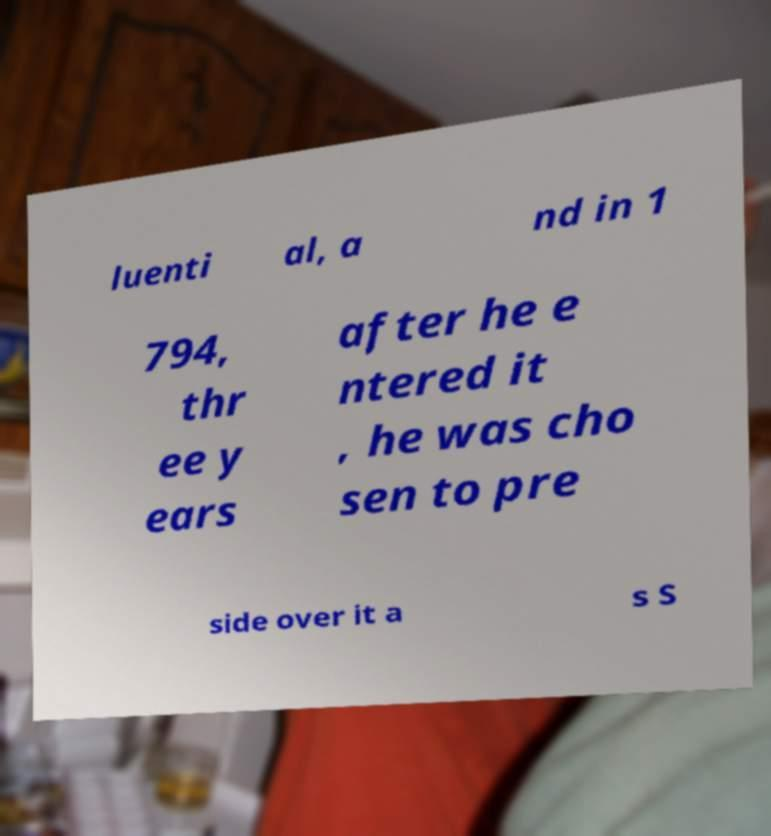Please identify and transcribe the text found in this image. luenti al, a nd in 1 794, thr ee y ears after he e ntered it , he was cho sen to pre side over it a s S 